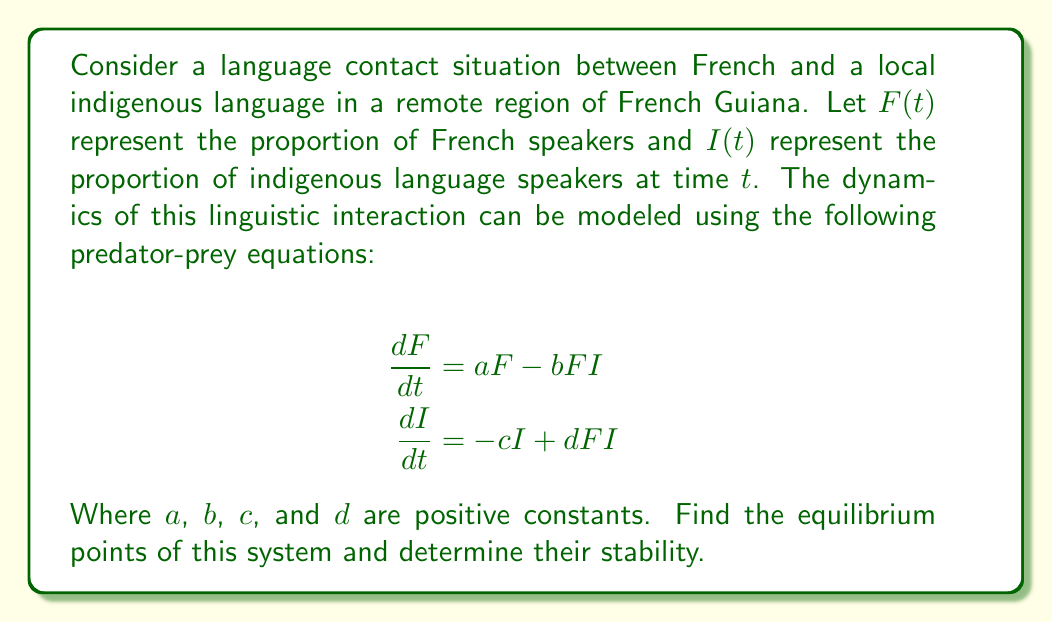Can you solve this math problem? To solve this problem, we'll follow these steps:

1) Find the equilibrium points by setting both equations to zero:

   $$\frac{dF}{dt} = aF - bFI = 0$$
   $$\frac{dI}{dt} = -cI + dFI = 0$$

2) From the first equation:
   $F(a - bI) = 0$, so either $F = 0$ or $I = \frac{a}{b}$

3) From the second equation:
   $I(-c + dF) = 0$, so either $I = 0$ or $F = \frac{c}{d}$

4) Combining these results, we get two equilibrium points:
   $(F, I) = (0, 0)$ and $(F, I) = (\frac{c}{d}, \frac{a}{b})$

5) To determine stability, we need to find the Jacobian matrix:

   $$J = \begin{bmatrix}
   \frac{\partial}{\partial F}(aF - bFI) & \frac{\partial}{\partial I}(aF - bFI) \\
   \frac{\partial}{\partial F}(-cI + dFI) & \frac{\partial}{\partial I}(-cI + dFI)
   \end{bmatrix}$$

   $$J = \begin{bmatrix}
   a - bI & -bF \\
   dI & -c + dF
   \end{bmatrix}$$

6) Evaluate J at (0, 0):

   $$J_{(0,0)} = \begin{bmatrix}
   a & 0 \\
   0 & -c
   \end{bmatrix}$$

   Eigenvalues are $a$ and $-c$. Since $a > 0$ and $-c < 0$, this is a saddle point (unstable).

7) Evaluate J at $(\frac{c}{d}, \frac{a}{b})$:

   $$J_{(\frac{c}{d}, \frac{a}{b})} = \begin{bmatrix}
   0 & -\frac{bc}{d} \\
   \frac{ad}{b} & 0
   \end{bmatrix}$$

   Eigenvalues are $\pm i\sqrt{ac}$. These are purely imaginary, indicating a center (neutrally stable).
Answer: Two equilibrium points: (0, 0) (unstable saddle) and $(\frac{c}{d}, \frac{a}{b})$ (neutrally stable center). 